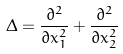<formula> <loc_0><loc_0><loc_500><loc_500>\Delta = \frac { \partial ^ { 2 } } { \partial x _ { 1 } ^ { 2 } } + \frac { \partial ^ { 2 } } { \partial x _ { 2 } ^ { 2 } }</formula> 